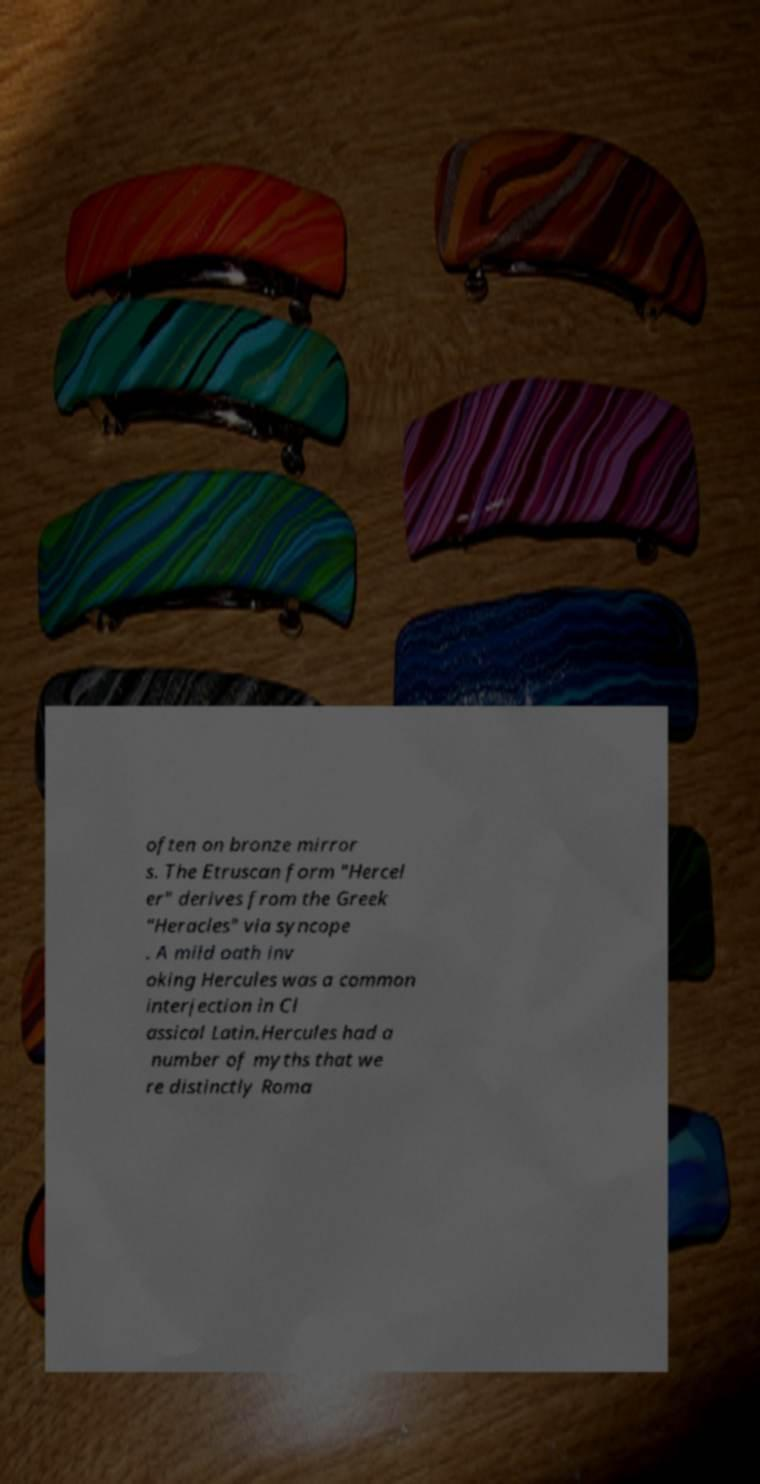Please identify and transcribe the text found in this image. often on bronze mirror s. The Etruscan form "Hercel er" derives from the Greek "Heracles" via syncope . A mild oath inv oking Hercules was a common interjection in Cl assical Latin.Hercules had a number of myths that we re distinctly Roma 